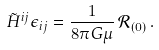<formula> <loc_0><loc_0><loc_500><loc_500>\tilde { H } ^ { i j } \epsilon _ { i j } = \frac { 1 } { 8 \pi G \mu } \, \mathcal { R } _ { ( 0 ) } \, .</formula> 